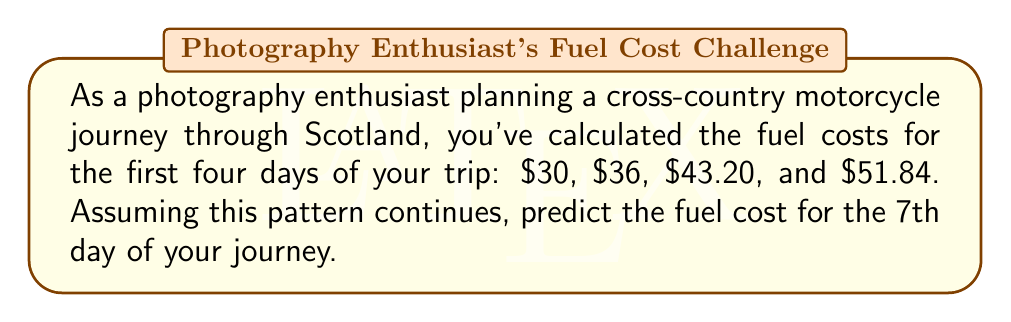Solve this math problem. Let's approach this step-by-step:

1) First, let's identify the pattern in the given sequence:
   $30, $36, $43.20, $51.84

2) To find the relationship between consecutive terms, let's divide each term by the previous one:

   $\frac{36}{30} = 1.2$
   $\frac{43.20}{36} = 1.2$
   $\frac{51.84}{43.20} = 1.2$

3) We can see that each term is 1.2 times the previous term. This is a geometric sequence with a common ratio of 1.2.

4) The general formula for a geometric sequence is:

   $a_n = a_1 \cdot r^{n-1}$

   Where $a_n$ is the nth term, $a_1$ is the first term, r is the common ratio, and n is the term number.

5) In this case:
   $a_1 = 30$
   $r = 1.2$
   We need to find $a_7$

6) Plugging into the formula:

   $a_7 = 30 \cdot (1.2)^{7-1} = 30 \cdot (1.2)^6$

7) Calculate:
   $30 \cdot (1.2)^6 = 30 \cdot 2.9859 = 89.577$

8) Rounding to cents:
   $89.58
Answer: $89.58 